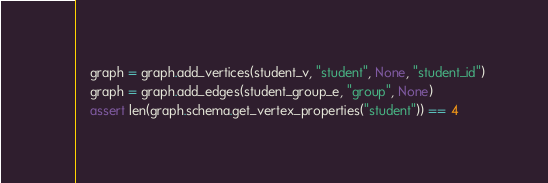<code> <loc_0><loc_0><loc_500><loc_500><_Python_>    graph = graph.add_vertices(student_v, "student", None, "student_id")
    graph = graph.add_edges(student_group_e, "group", None)
    assert len(graph.schema.get_vertex_properties("student")) == 4</code> 